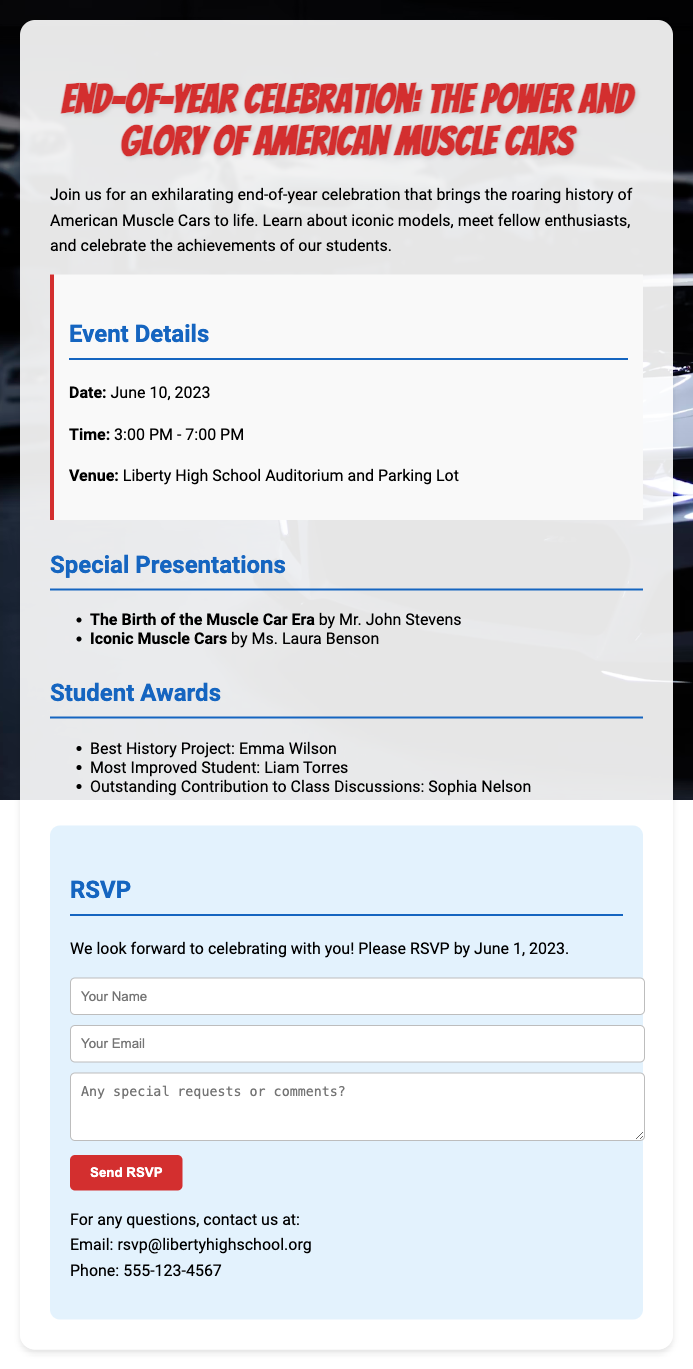What is the date of the event? The date is specified in the document under event details.
Answer: June 10, 2023 What time does the celebration start? The start time is explicitly mentioned in the event details section.
Answer: 3:00 PM Who is giving the presentation on iconic muscle cars? The presenter's name is listed under special presentations.
Answer: Ms. Laura Benson What is the location of the event? The venue is provided in the event details section.
Answer: Liberty High School Auditorium and Parking Lot What award did Emma Wilson receive? Emma Wilson's award is noted in the student awards section.
Answer: Best History Project How many special presentations are there? The number of presentations can be counted from the special presentations section.
Answer: 2 What is the deadline for RSVPing? The RSVP deadline is explicitly stated in the RSVP section of the document.
Answer: June 1, 2023 What type of document is this? The document is designed to gather RSVP responses for an event.
Answer: RSVP card 